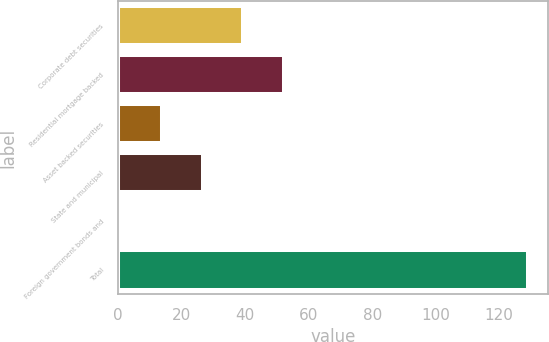<chart> <loc_0><loc_0><loc_500><loc_500><bar_chart><fcel>Corporate debt securities<fcel>Residential mortgage backed<fcel>Asset backed securities<fcel>State and municipal<fcel>Foreign government bonds and<fcel>Total<nl><fcel>39.4<fcel>52.2<fcel>13.8<fcel>26.6<fcel>1<fcel>129<nl></chart> 